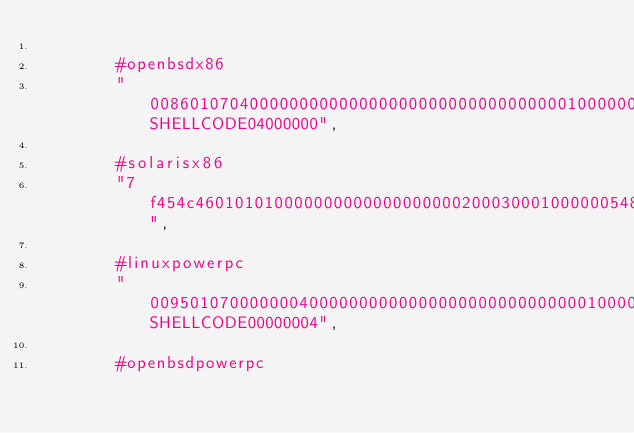<code> <loc_0><loc_0><loc_500><loc_500><_Python_>
        #openbsdx86
        "0086010704000000000000000000000000000000001000000000000000000000SHELLCODE04000000",

        #solarisx86
        "7f454c460101010000000000000000000200030001000000548004083400000000000000000000003400200001000000000000000100000000000000008004080080040858000000001000000700000000100000SHELLCODE",

        #linuxpowerpc
        "0095010700000004000000000000000000000000000010000000000000000000SHELLCODE00000004",

        #openbsdpowerpc</code> 